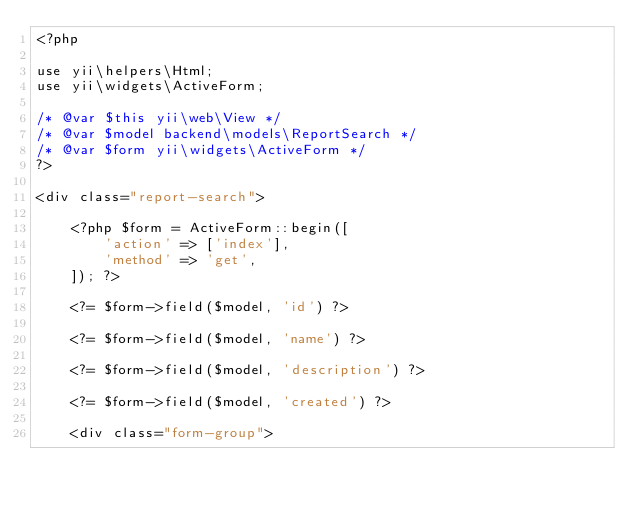<code> <loc_0><loc_0><loc_500><loc_500><_PHP_><?php

use yii\helpers\Html;
use yii\widgets\ActiveForm;

/* @var $this yii\web\View */
/* @var $model backend\models\ReportSearch */
/* @var $form yii\widgets\ActiveForm */
?>

<div class="report-search">

    <?php $form = ActiveForm::begin([
        'action' => ['index'],
        'method' => 'get',
    ]); ?>

    <?= $form->field($model, 'id') ?>

    <?= $form->field($model, 'name') ?>

    <?= $form->field($model, 'description') ?>

    <?= $form->field($model, 'created') ?>

    <div class="form-group"></code> 